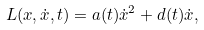<formula> <loc_0><loc_0><loc_500><loc_500>L ( x , \dot { x } , t ) = a ( t ) \dot { x } ^ { 2 } + d ( t ) \dot { x } ,</formula> 